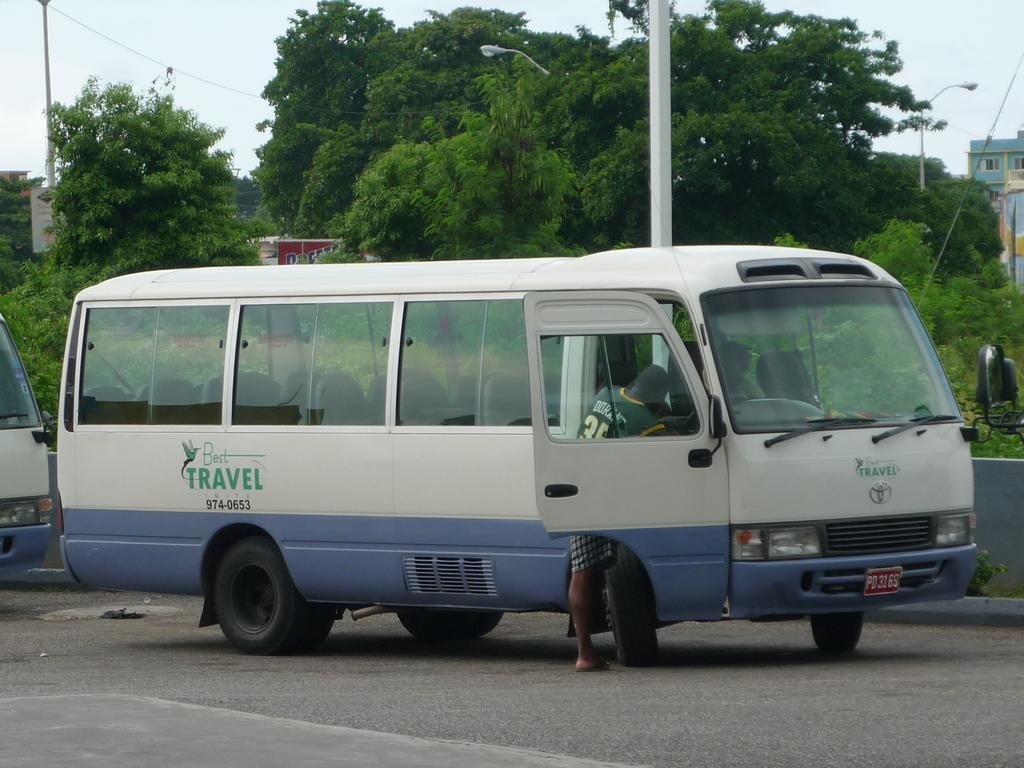<image>
Write a terse but informative summary of the picture. White and blue van which has the word "Travel" on the side. 